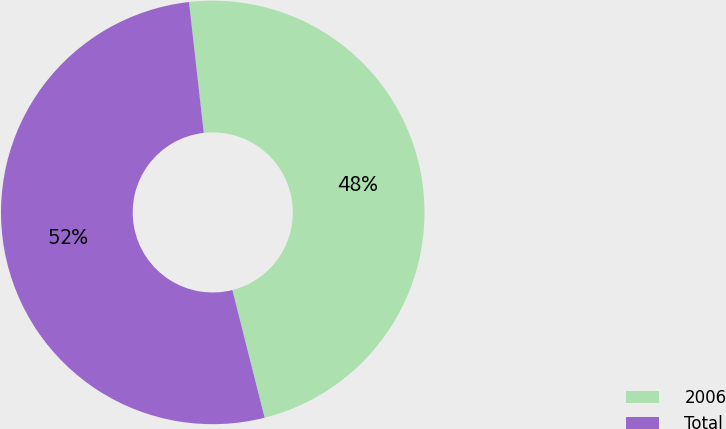<chart> <loc_0><loc_0><loc_500><loc_500><pie_chart><fcel>2006<fcel>Total<nl><fcel>47.85%<fcel>52.15%<nl></chart> 